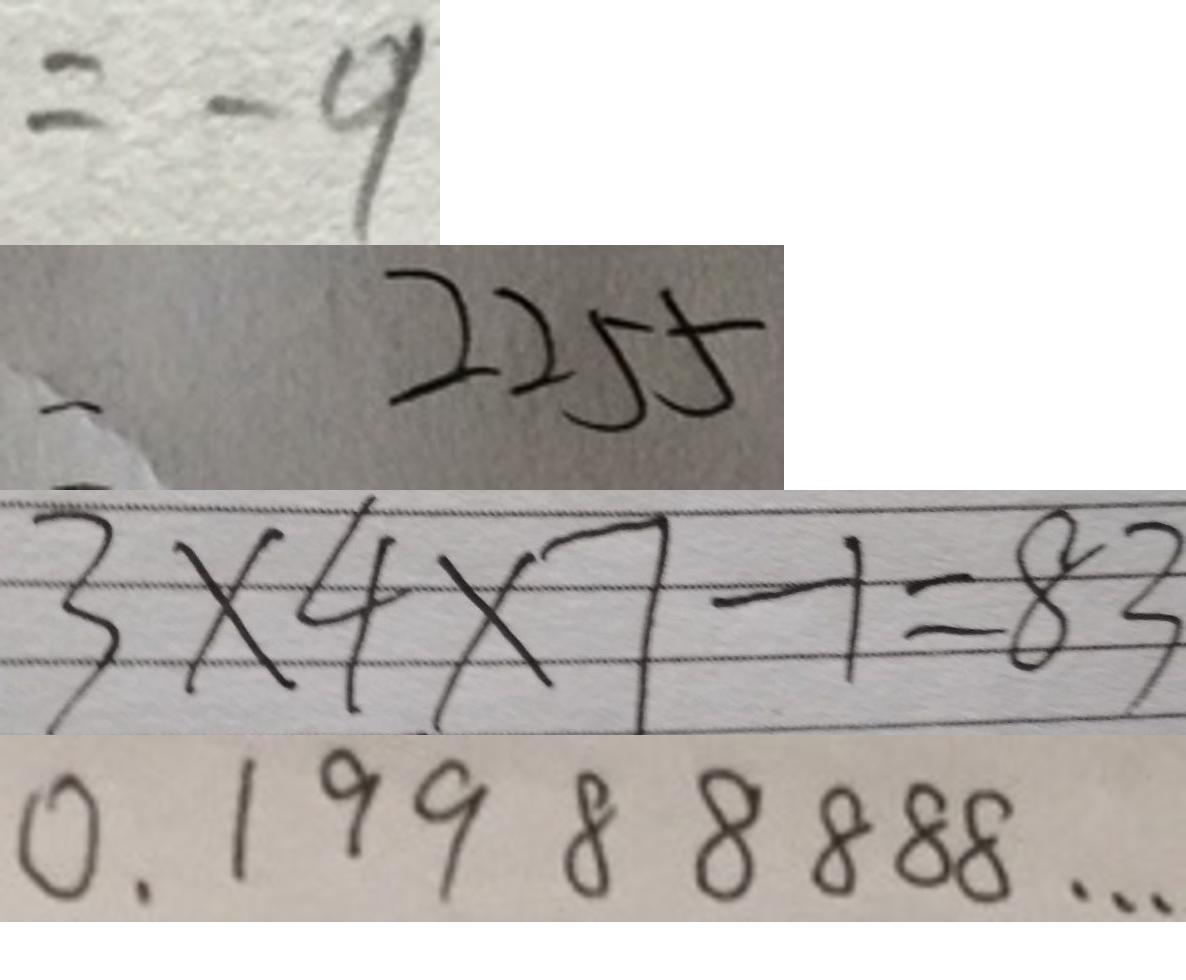<formula> <loc_0><loc_0><loc_500><loc_500>= - 9 
 = 2 2 5 5 
 3 \times 4 \times 7 - 1 = 8 3 
 0 . 1 9 9 8 8 8 8 8 \cdots</formula> 